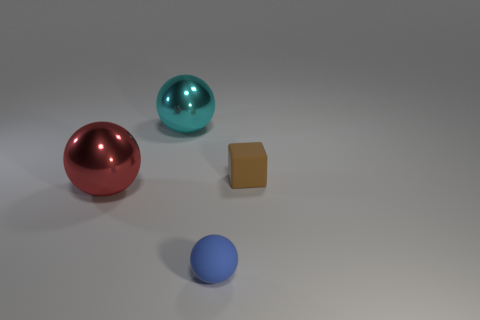What could be the purpose of these objects, considering their shapes and sizes? Given their simple geometric shapes and varying sizes, these objects could serve an educational purpose, such as teaching about geometry, size comparison, or color identification. They could also be used in a variety of visual arts to demonstrate concepts like perspective, shading, and composition. 